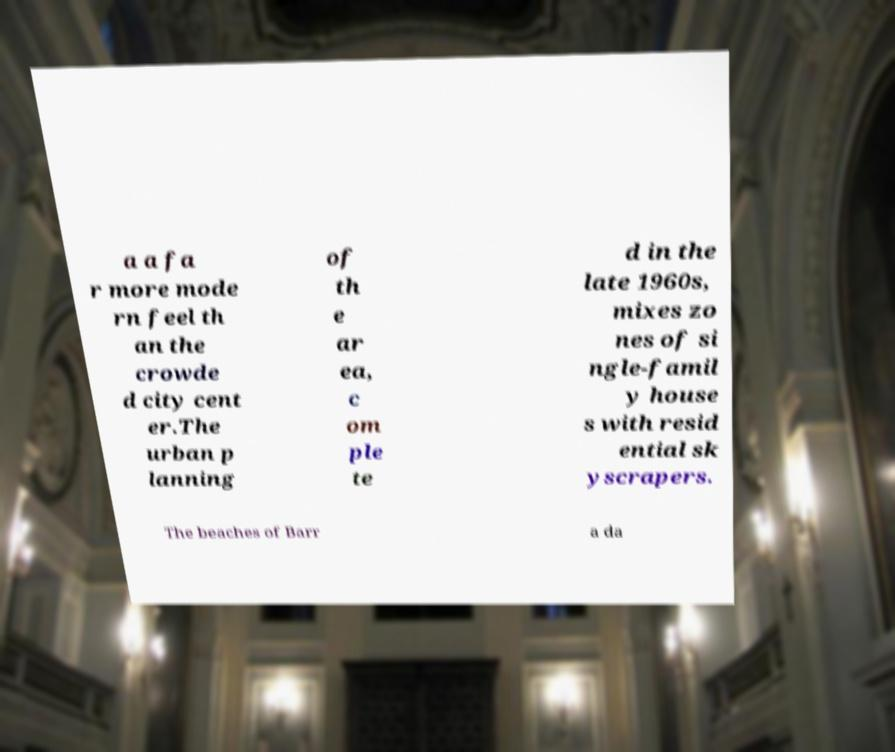I need the written content from this picture converted into text. Can you do that? a a fa r more mode rn feel th an the crowde d city cent er.The urban p lanning of th e ar ea, c om ple te d in the late 1960s, mixes zo nes of si ngle-famil y house s with resid ential sk yscrapers. The beaches of Barr a da 